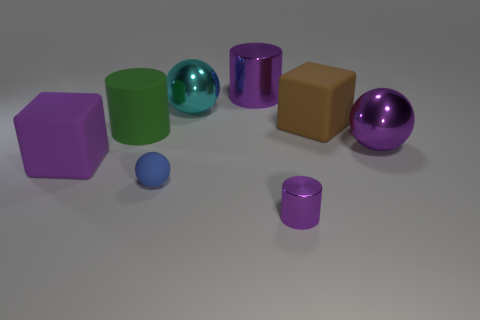Subtract all large balls. How many balls are left? 1 Subtract all cyan balls. How many balls are left? 2 Subtract all balls. How many objects are left? 5 Add 2 purple metallic cubes. How many objects exist? 10 Add 3 big metallic cylinders. How many big metallic cylinders are left? 4 Add 7 big cyan matte things. How many big cyan matte things exist? 7 Subtract 0 brown cylinders. How many objects are left? 8 Subtract all purple balls. Subtract all brown blocks. How many balls are left? 2 Subtract all yellow cubes. How many cyan balls are left? 1 Subtract all tiny cyan metallic cubes. Subtract all matte blocks. How many objects are left? 6 